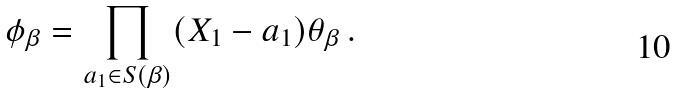<formula> <loc_0><loc_0><loc_500><loc_500>\phi _ { \beta } = \prod _ { a _ { 1 } \in S ( \beta ) } ( X _ { 1 } - a _ { 1 } ) \theta _ { \beta } \, .</formula> 